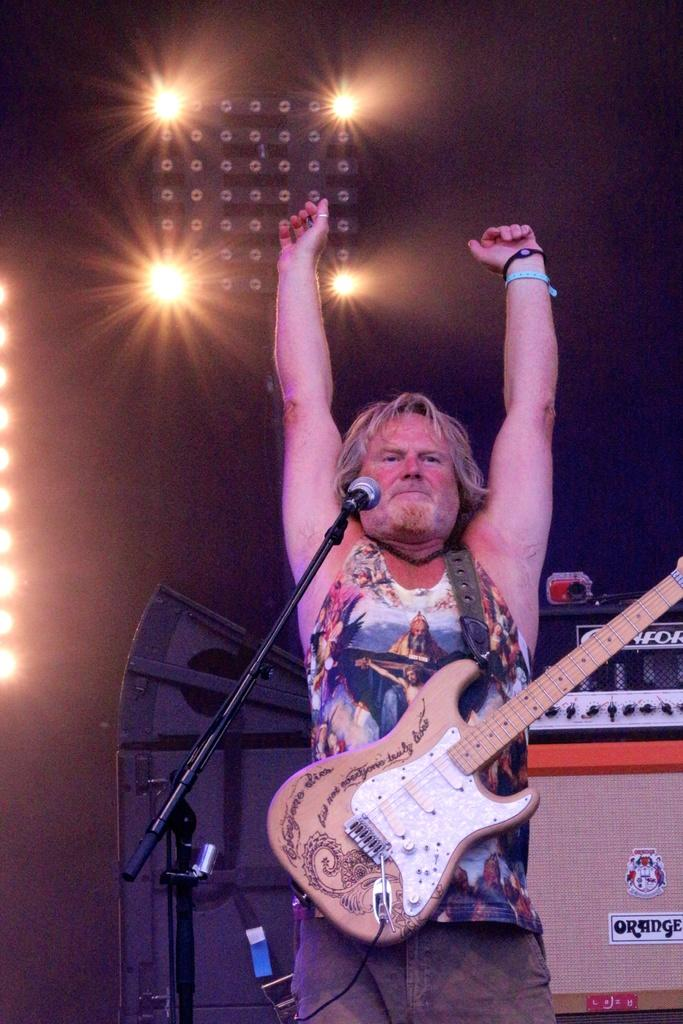What is the man in the image holding? The man is holding a guitar. What is in front of the man that might be used for amplifying his voice? There is a microphone with a stand in front of the man. What equipment is visible behind the man? There are music systems behind the man. What can be seen in the background that might be used for lighting? There is a pole with lights in the background. What type of quiver is the man using to hold his guitar strings? The man is not using a quiver to hold his guitar strings; he is simply holding the guitar. 